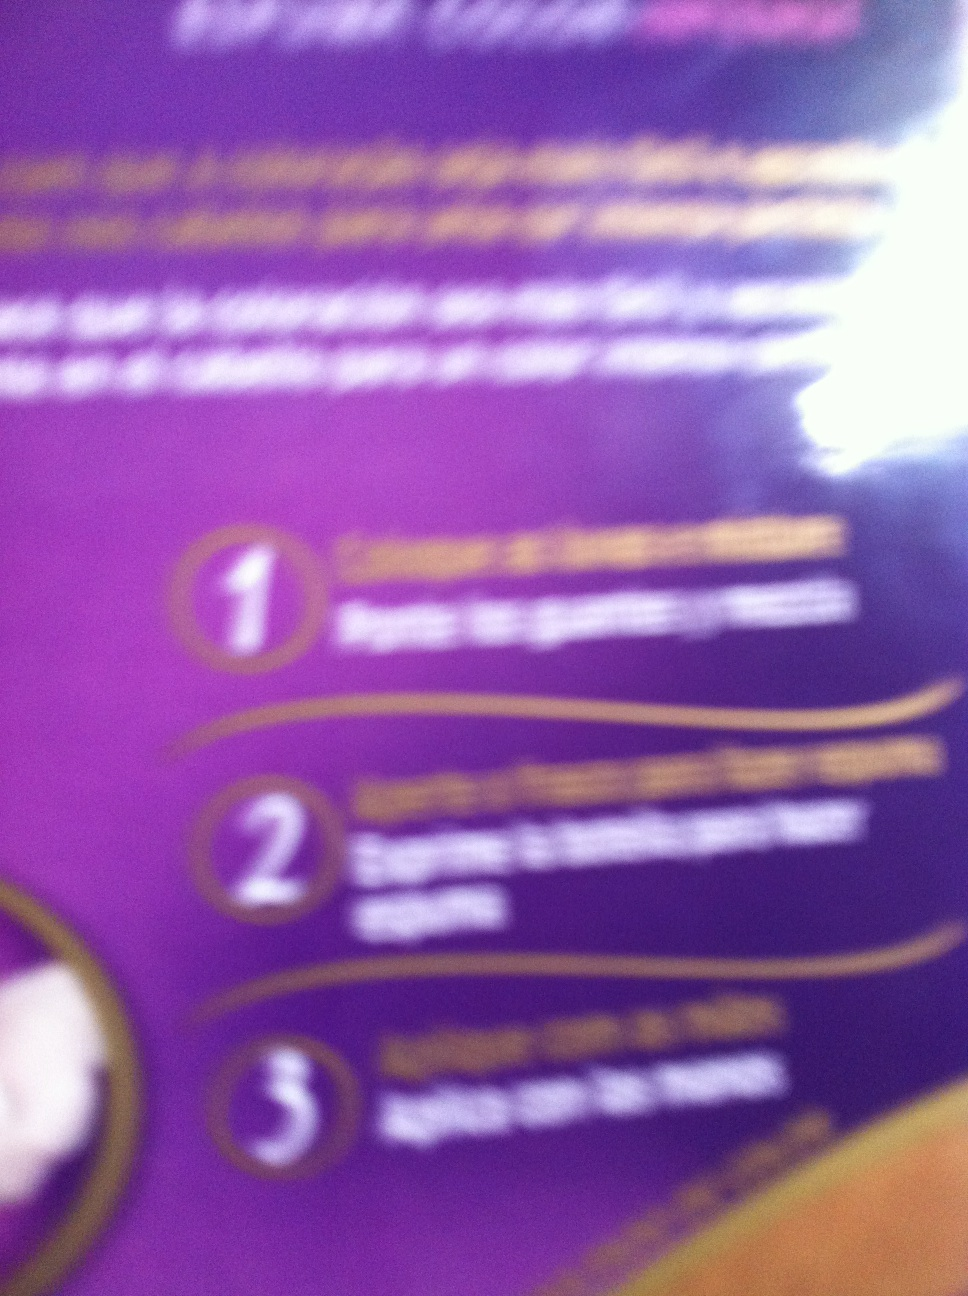What's a short, realistic scenario for using this product? After washing their face in the evening, a person might apply this product to ensure their skin remains moisturized overnight. 